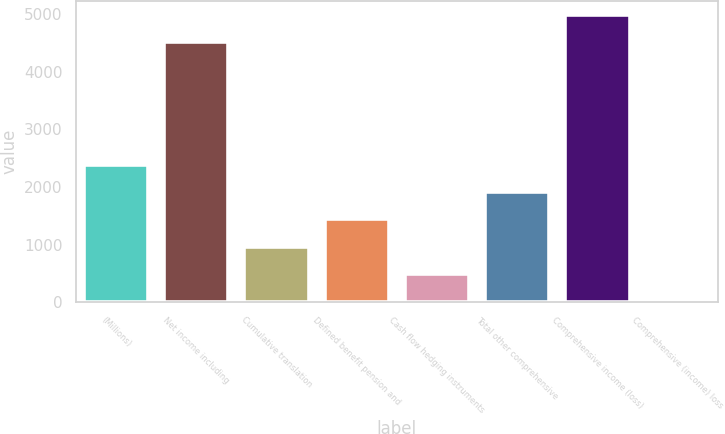Convert chart to OTSL. <chart><loc_0><loc_0><loc_500><loc_500><bar_chart><fcel>(Millions)<fcel>Net income including<fcel>Cumulative translation<fcel>Defined benefit pension and<fcel>Cash flow hedging instruments<fcel>Total other comprehensive<fcel>Comprehensive income (loss)<fcel>Comprehensive (income) loss<nl><fcel>2382.5<fcel>4511<fcel>966.8<fcel>1438.7<fcel>494.9<fcel>1910.6<fcel>4982.9<fcel>23<nl></chart> 